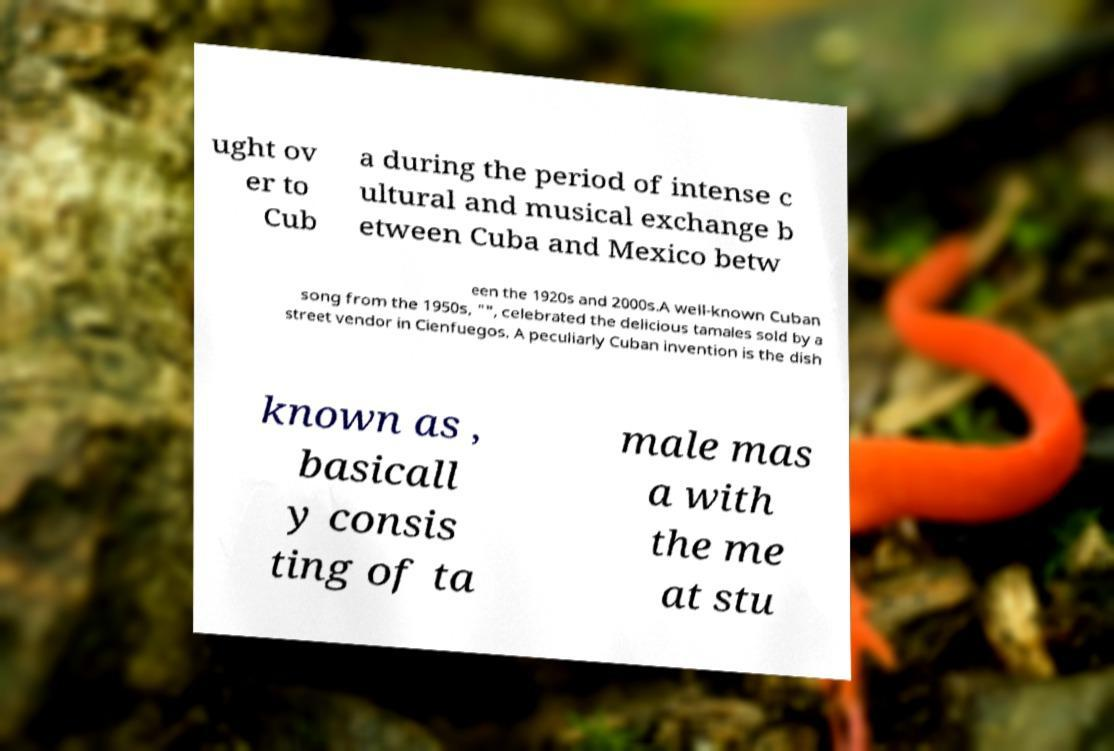Please read and relay the text visible in this image. What does it say? ught ov er to Cub a during the period of intense c ultural and musical exchange b etween Cuba and Mexico betw een the 1920s and 2000s.A well-known Cuban song from the 1950s, "", celebrated the delicious tamales sold by a street vendor in Cienfuegos. A peculiarly Cuban invention is the dish known as , basicall y consis ting of ta male mas a with the me at stu 